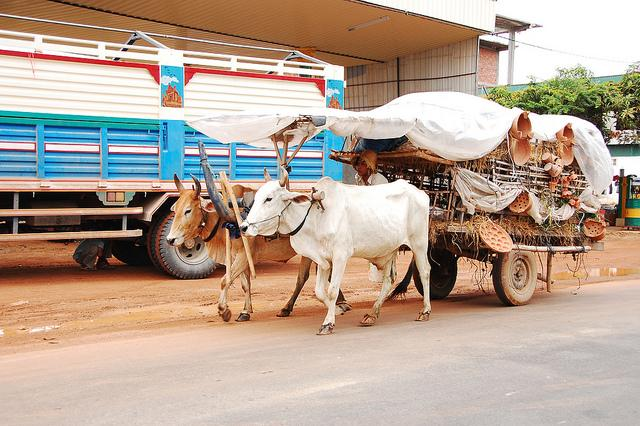What are the bulls doing?

Choices:
A) sleeping
B) resting
C) grazing
D) working working 